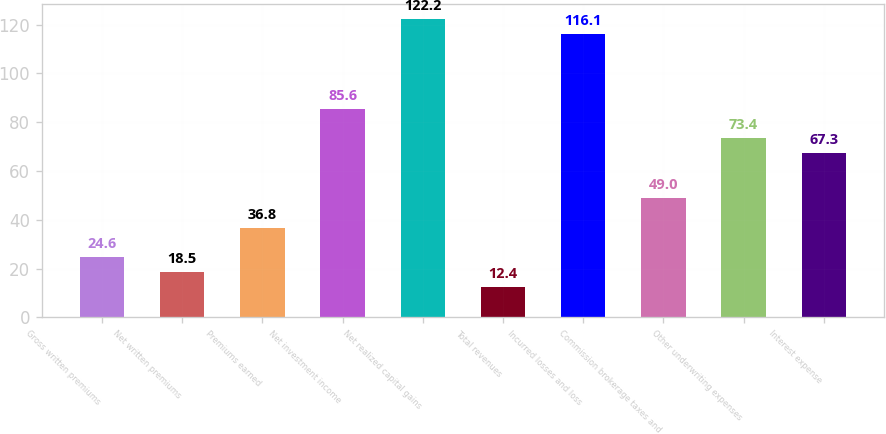Convert chart to OTSL. <chart><loc_0><loc_0><loc_500><loc_500><bar_chart><fcel>Gross written premiums<fcel>Net written premiums<fcel>Premiums earned<fcel>Net investment income<fcel>Net realized capital gains<fcel>Total revenues<fcel>Incurred losses and loss<fcel>Commission brokerage taxes and<fcel>Other underwriting expenses<fcel>Interest expense<nl><fcel>24.6<fcel>18.5<fcel>36.8<fcel>85.6<fcel>122.2<fcel>12.4<fcel>116.1<fcel>49<fcel>73.4<fcel>67.3<nl></chart> 